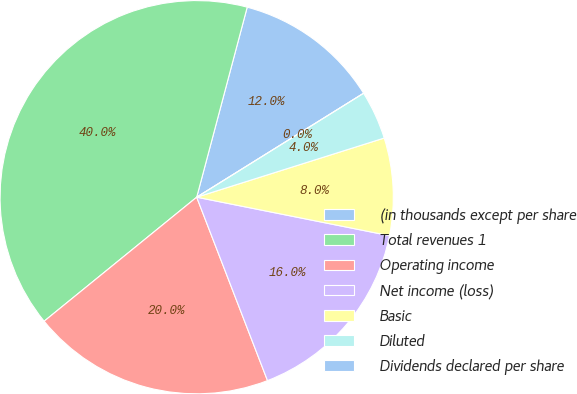Convert chart to OTSL. <chart><loc_0><loc_0><loc_500><loc_500><pie_chart><fcel>(in thousands except per share<fcel>Total revenues 1<fcel>Operating income<fcel>Net income (loss)<fcel>Basic<fcel>Diluted<fcel>Dividends declared per share<nl><fcel>12.0%<fcel>40.0%<fcel>20.0%<fcel>16.0%<fcel>8.0%<fcel>4.0%<fcel>0.0%<nl></chart> 